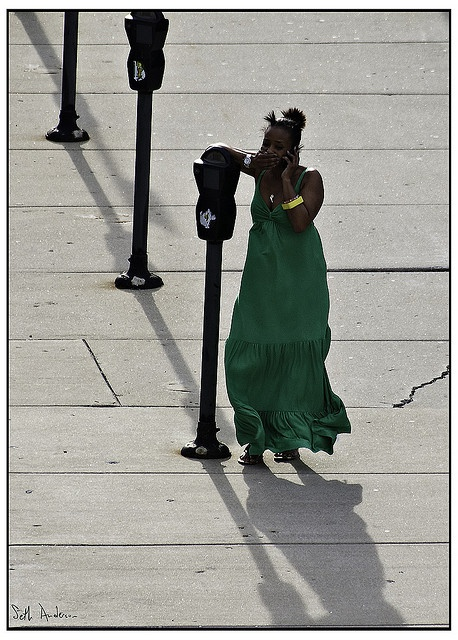Describe the objects in this image and their specific colors. I can see people in white, black, darkgreen, teal, and gray tones, parking meter in white, black, gray, darkgray, and lightgray tones, parking meter in white, black, lightgray, darkgray, and gray tones, cell phone in black, gray, and white tones, and cell phone in white, darkgray, black, lightgray, and gray tones in this image. 